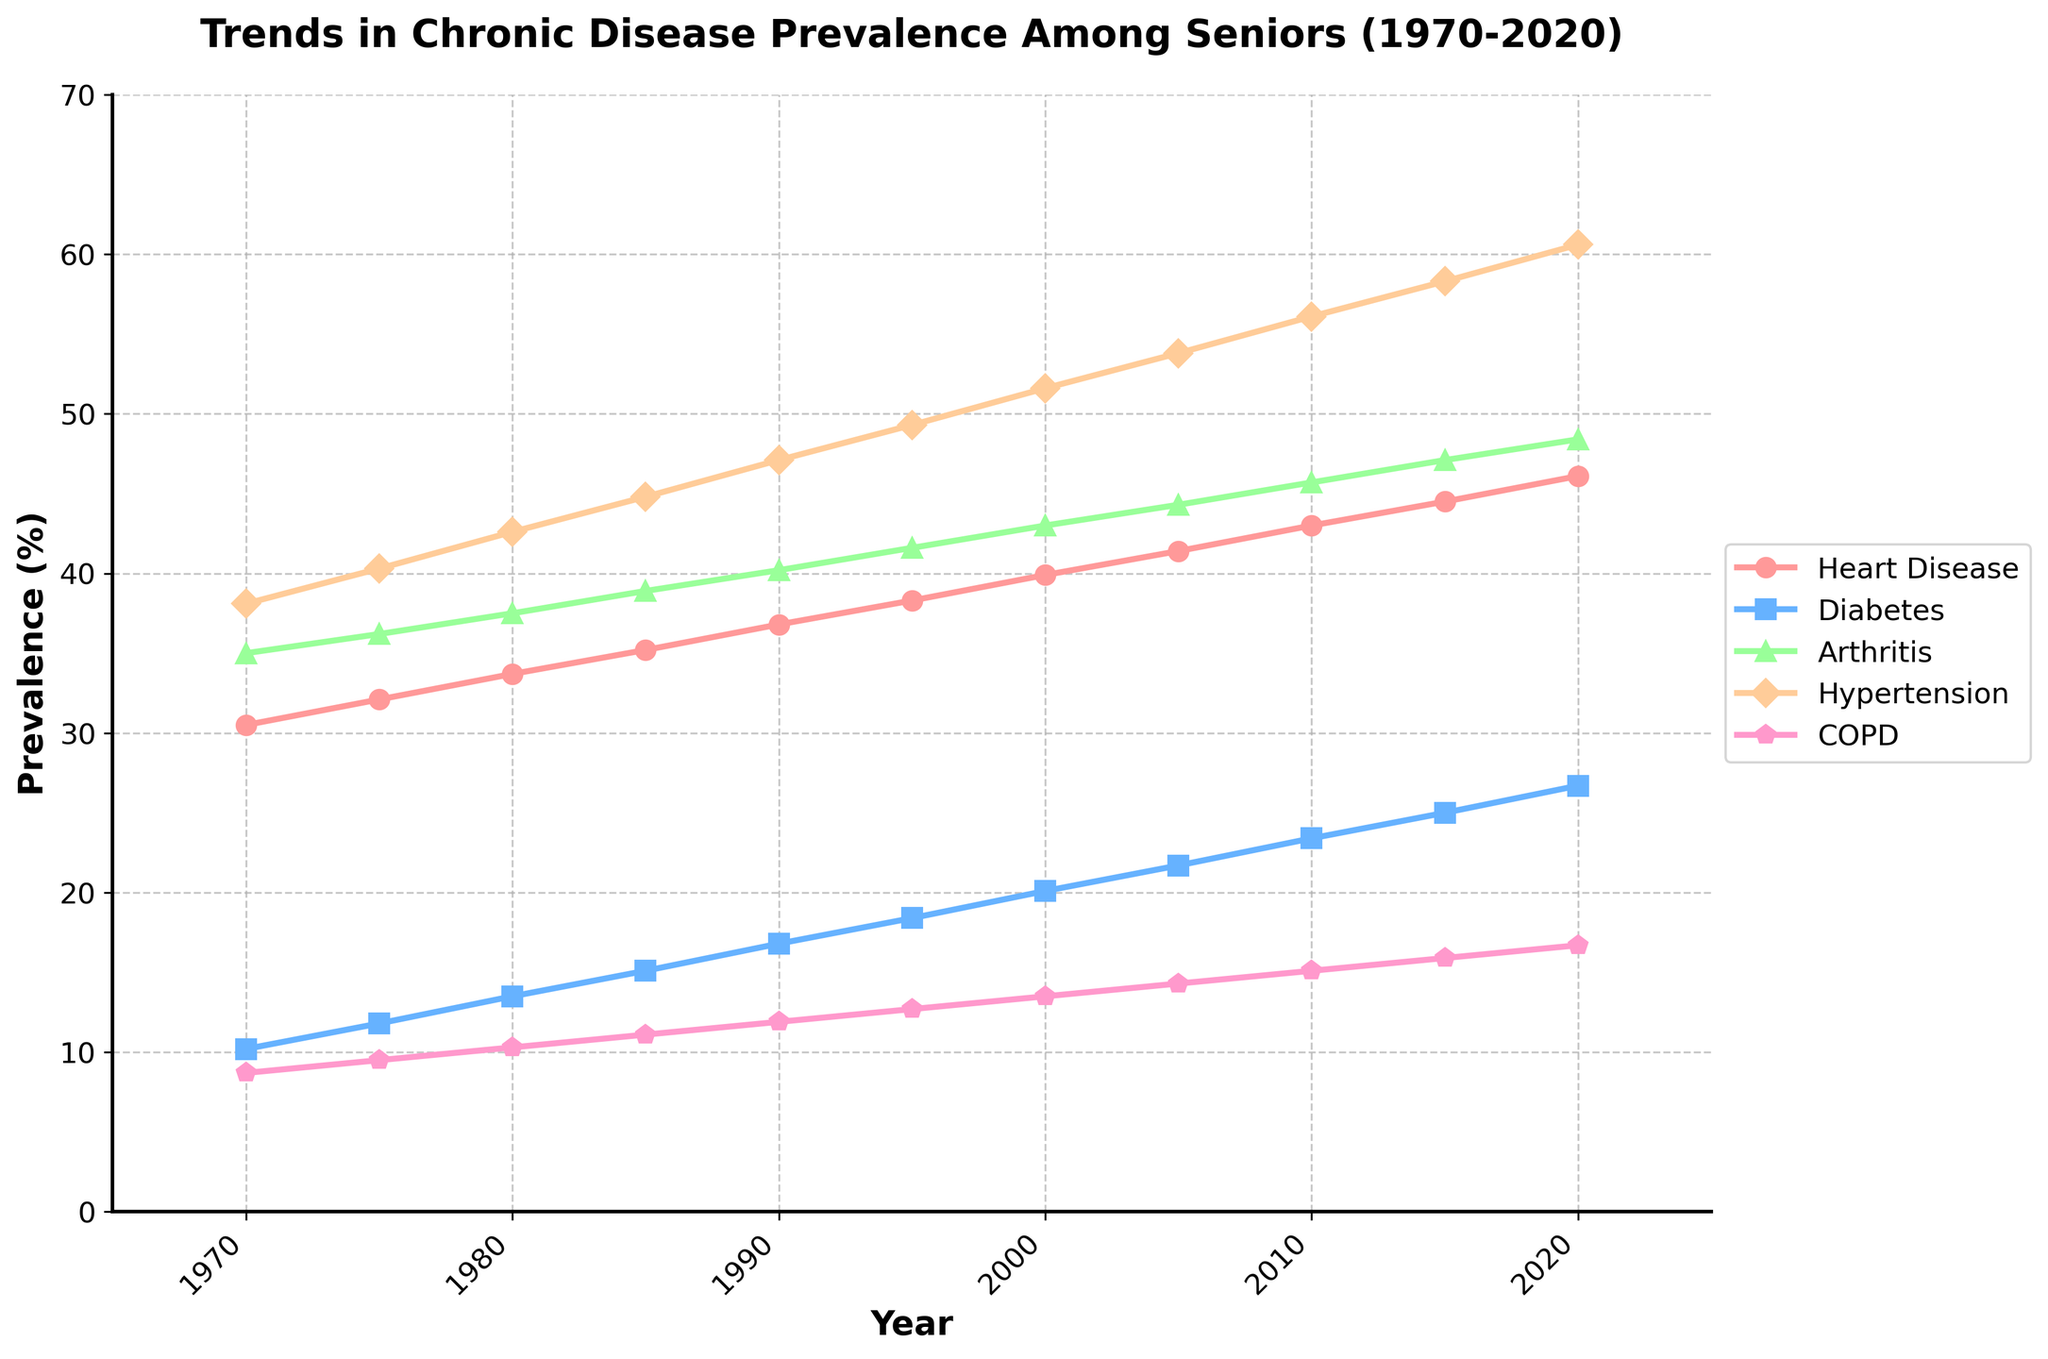What is the general trend in the prevalence of heart disease among seniors from 1970 to 2020? From 1970 to 2020, the line representing heart disease shows a steady upward trend. It starts at 30.5% in 1970 and rises consistently, reaching 46.1% in 2020.
Answer: Increasing Which chronic disease saw the highest increase in prevalence from 1970 to 2020? By visually comparing the starting and ending points of all the lines, we see that hypertension has the most significant change, starting at 38.1% in 1970 and increasing to 60.6% in 2020.
Answer: Hypertension Between 1985 and 2000, which chronic disease had the smallest increase in prevalence? By examining the changes between 1985 and 2000 for each condition, we find the changes to be: Heart Disease (4.7%), Diabetes (5.0%), Arthritis (4.1%), Hypertension (6.8%), COPD (2.4%). COPD had the smallest increase.
Answer: COPD Which condition had a higher prevalence than heart disease in 1980? By checking the value of heart disease in 1980, which is 33.7%, and comparing it with other conditions, arthritis (37.5%) and hypertension (42.6%) are higher.
Answer: Arthritis and Hypertension What is the total prevalence percentage of arthritis and COPD in 1990? Summing the values for arthritis (40.2%) and COPD (11.9%) in 1990: 40.2 + 11.9 = 52.1%.
Answer: 52.1% In which year did diabetes surpass 20% prevalence? The plot shows diabetes approaching 20% incrementally. Referring to the timeline, diabetes reached 20.1% in the year 2000.
Answer: 2000 Which chronic disease shows the steepest slope (indicating the fastest rate of increase) between 2005 and 2015? By comparing the slopes, hypertension shows the steepest increase. From 53.8% in 2005 to 58.3% in 2015, it increased by 4.5 percentage points over ten years.
Answer: Hypertension Is the prevalence of COPD higher or lower than diabetes by 2015, and by how much? In 2015, COPD is at 15.9% and diabetes at 25.0%. The difference is 25.0 - 15.9 = 9.1%. Thus, COPD is lower than diabetes by 9.1%.
Answer: Lower by 9.1% How does the prevalence of arthritis in 2000 compare to heart disease in 1995? In 2000, arthritis is at 43.0%, and in 1995, heart disease is at 38.3%. Arthritis prevalence in 2000 is higher than heart disease in 1995 by 4.7 percentage points.
Answer: Arthritis higher by 4.7% What is the average prevalence of hypertension between 1990 and 2020? The values are 47.1, 49.3, 51.6, 53.8, 56.1, 58.3, and 60.6. Summing them: 47.1 + 49.3 + 51.6 + 53.8 + 56.1 + 58.3 + 60.6 = 376.8. Dividing by the number of years (7): 376.8 / 7 = 53.83%.
Answer: 53.83% 